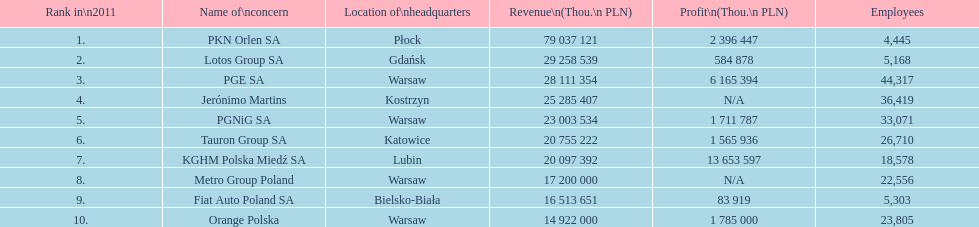What is the count of workers employed by pgnig sa? 33,071. 